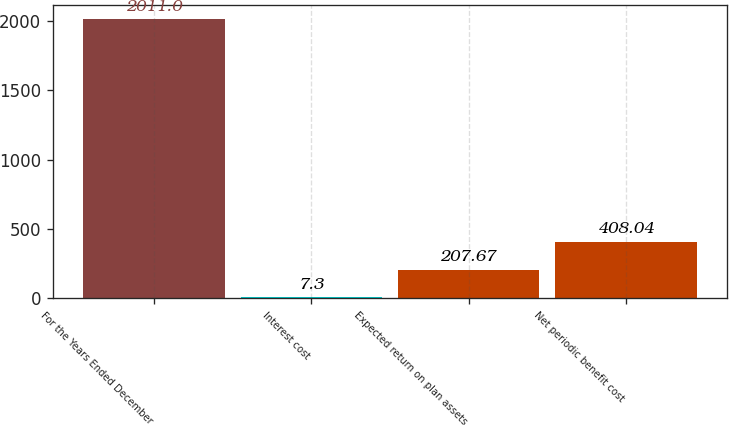Convert chart. <chart><loc_0><loc_0><loc_500><loc_500><bar_chart><fcel>For the Years Ended December<fcel>Interest cost<fcel>Expected return on plan assets<fcel>Net periodic benefit cost<nl><fcel>2011<fcel>7.3<fcel>207.67<fcel>408.04<nl></chart> 